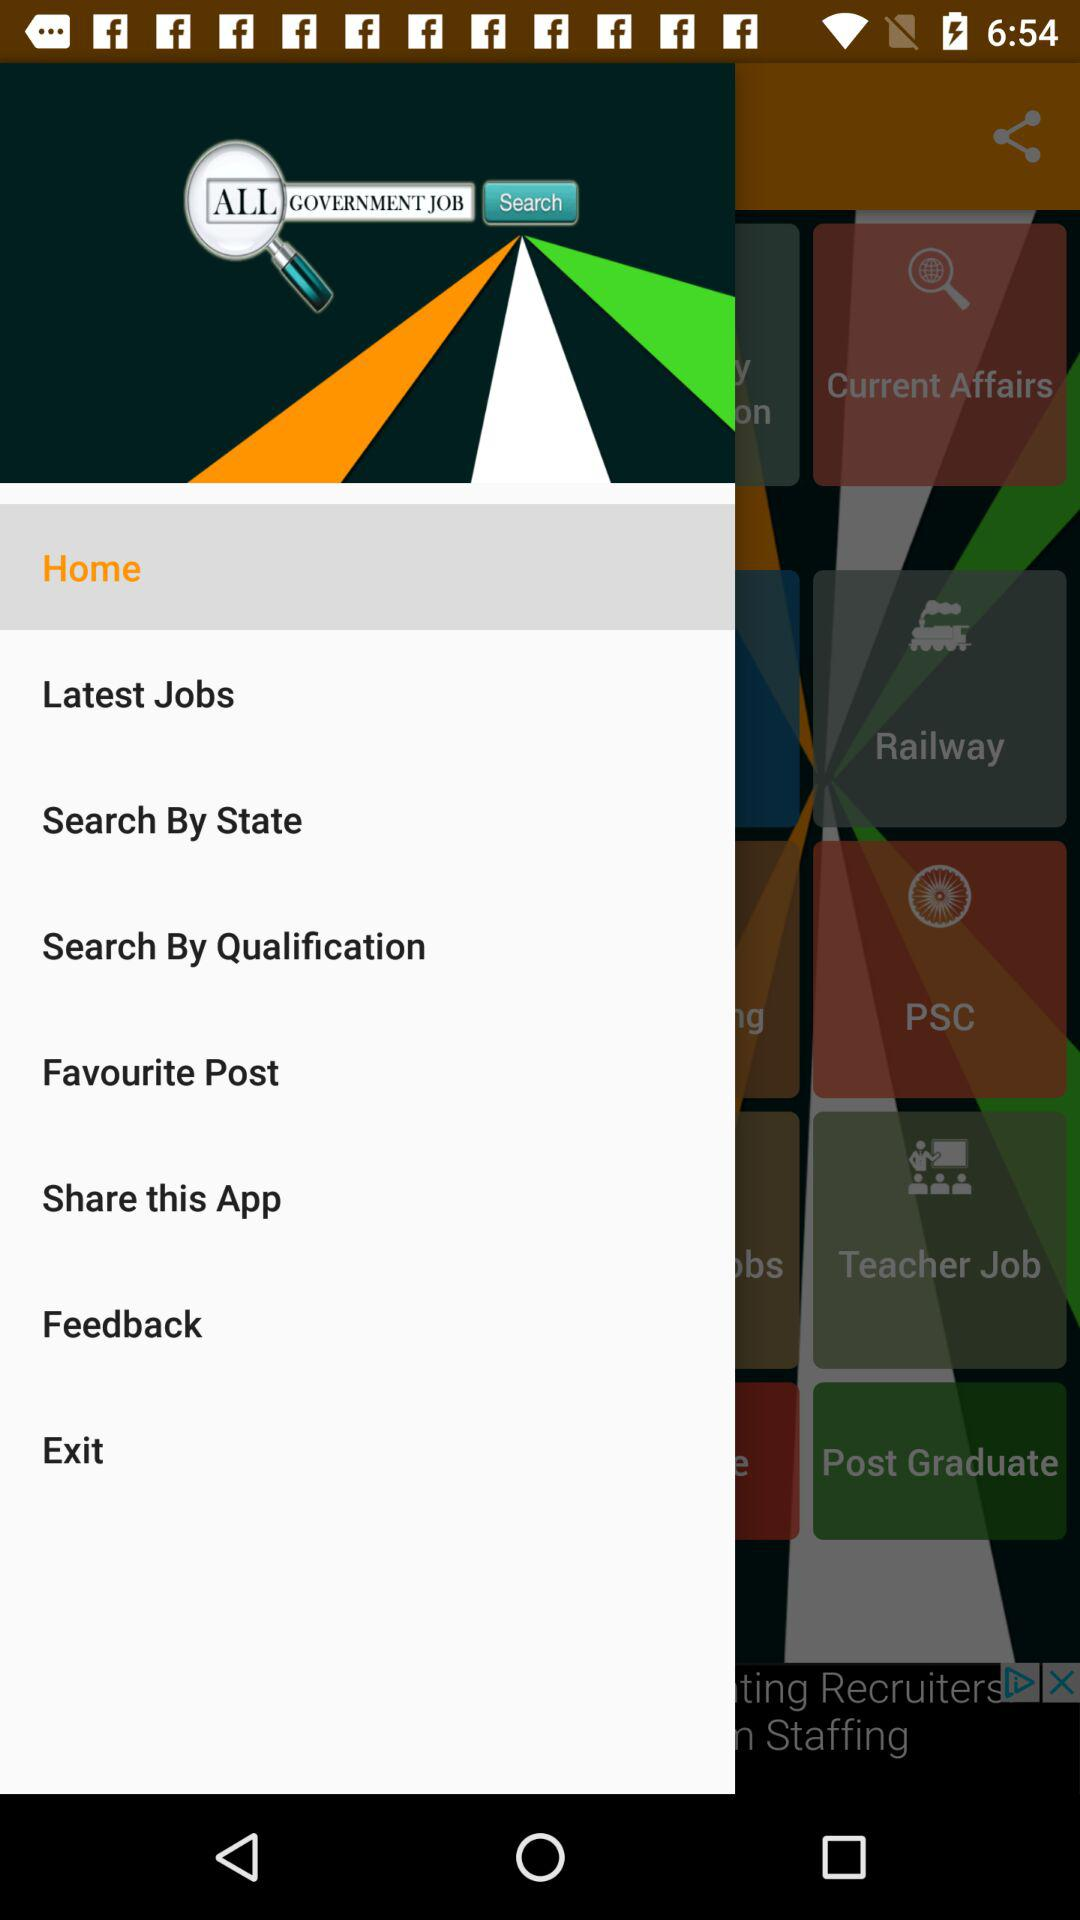Which item is selected? The selected item is "Home". 